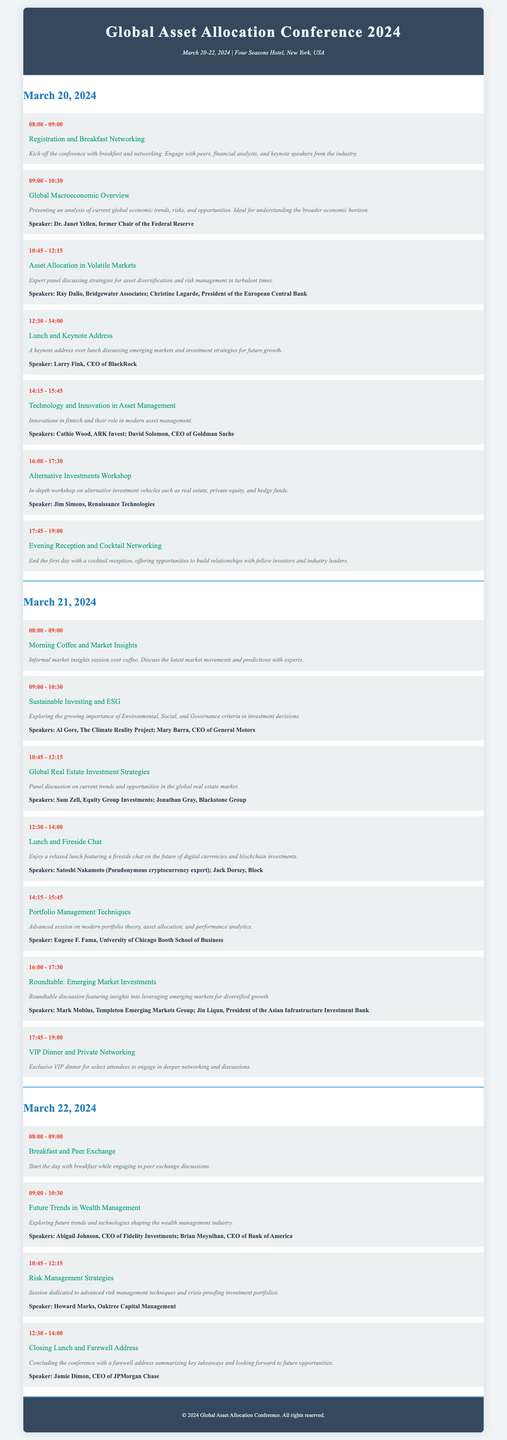What are the conference dates? The dates are provided in the conference info section, stating March 20-22, 2024.
Answer: March 20-22, 2024 Who is the speaker for the Keynote Address? The session description for Lunch and Keynote Address mentions Larry Fink as the speaker.
Answer: Larry Fink What time does the Evening Reception start? This information can be found in the session time details for the Evening Reception and states 17:45.
Answer: 17:45 Which session focuses on Sustainable Investing? The session title provided lists the specific session about Sustainable Investing and ESG.
Answer: Sustainable Investing and ESG How many sessions are scheduled on March 21, 2024? The day section lists a total of six sessions taking place on that date.
Answer: Six sessions Who are the speakers for the session on Global Real Estate Investment Strategies? The session description lists the speakers for that particular session, which includes Sam Zell and Jonathan Gray.
Answer: Sam Zell, Jonathan Gray What is the theme of the workshop on March 20, 2024? The title of the session indicates that the theme is Alternative Investments.
Answer: Alternative Investments Workshop What is included in the closing session of the conference? The session title and description indicate a Closing Lunch and Farewell Address summarizes key takeaways.
Answer: Closing Lunch and Farewell Address What type of networking opportunity occurs after the sessions on March 20, 2024? The document describes an Evening Reception and Cocktail Networking as the opportunity for the attendees.
Answer: Evening Reception and Cocktail Networking 